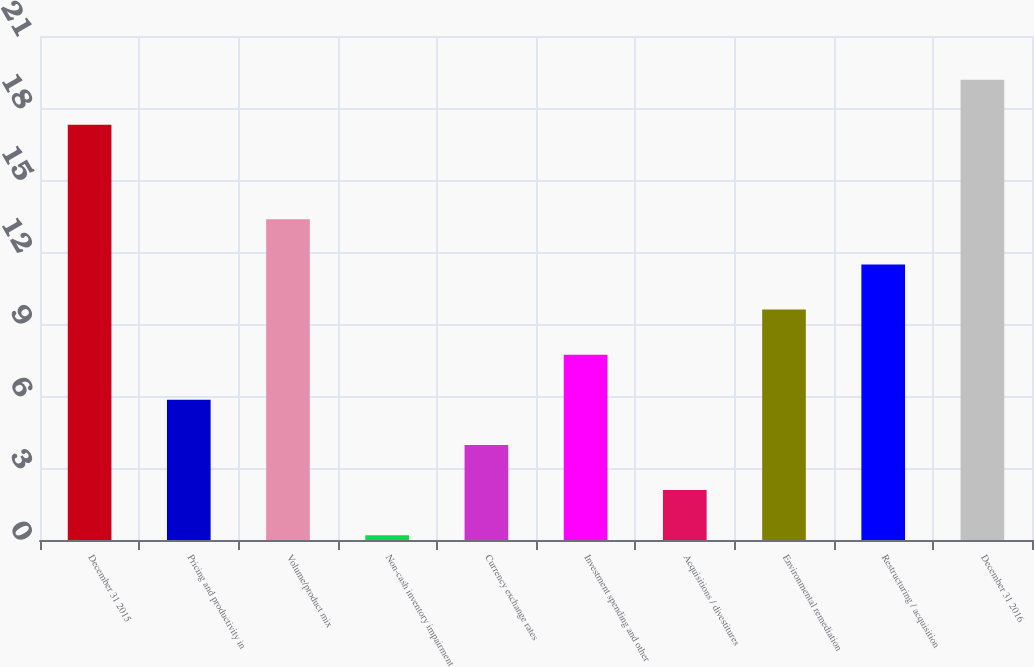Convert chart. <chart><loc_0><loc_0><loc_500><loc_500><bar_chart><fcel>December 31 2015<fcel>Pricing and productivity in<fcel>Volume/product mix<fcel>Non-cash inventory impairment<fcel>Currency exchange rates<fcel>Investment spending and other<fcel>Acquisitions / divestitures<fcel>Environmental remediation<fcel>Restructuring / acquisition<fcel>December 31 2016<nl><fcel>17.3<fcel>5.84<fcel>13.36<fcel>0.2<fcel>3.96<fcel>7.72<fcel>2.08<fcel>9.6<fcel>11.48<fcel>19.18<nl></chart> 